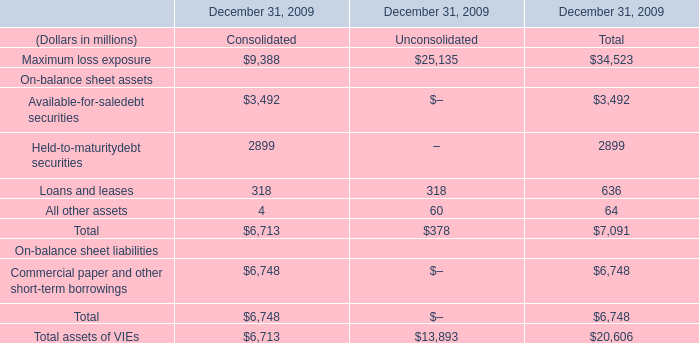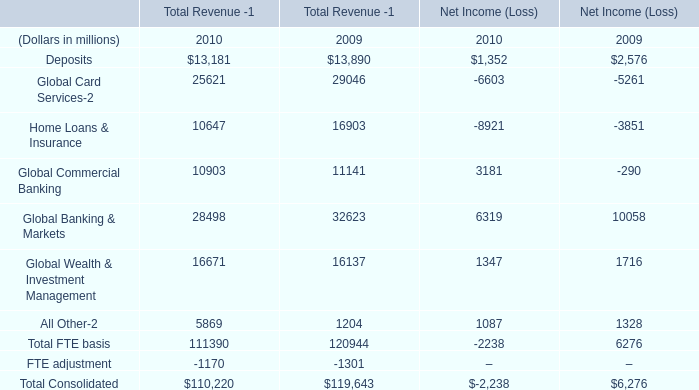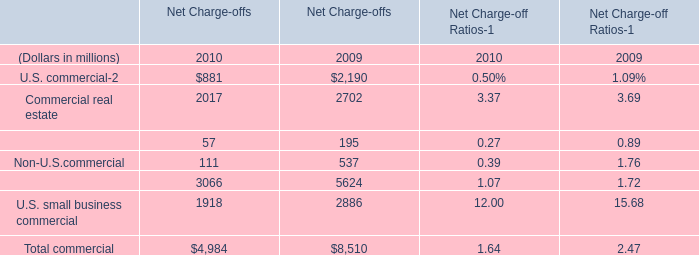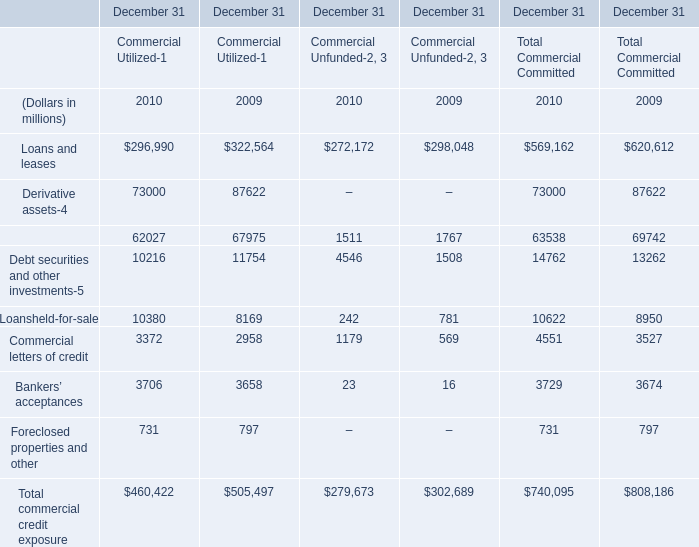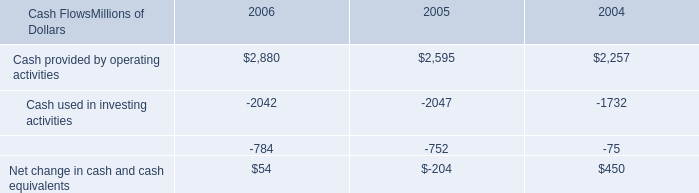What's the average of U.S. commercial and Commercial real estate in 2010 for Net Charge-offs? (in million) 
Computations: ((881 + 2017) / 2)
Answer: 1449.0. 